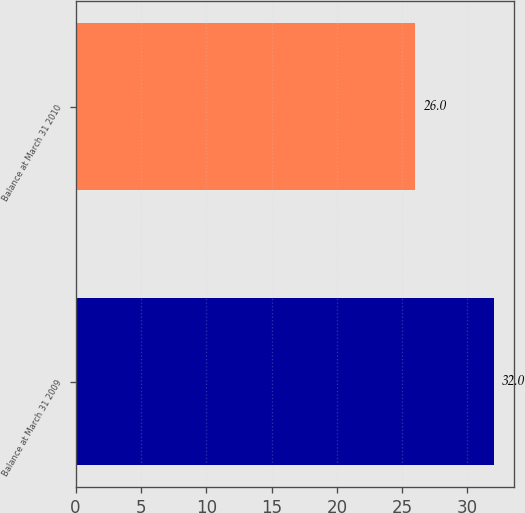<chart> <loc_0><loc_0><loc_500><loc_500><bar_chart><fcel>Balance at March 31 2009<fcel>Balance at March 31 2010<nl><fcel>32<fcel>26<nl></chart> 